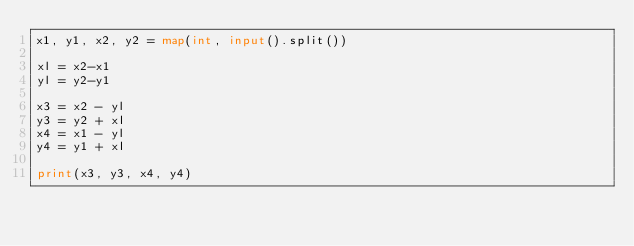<code> <loc_0><loc_0><loc_500><loc_500><_Python_>x1, y1, x2, y2 = map(int, input().split())

xl = x2-x1
yl = y2-y1

x3 = x2 - yl
y3 = y2 + xl
x4 = x1 - yl
y4 = y1 + xl

print(x3, y3, x4, y4)</code> 